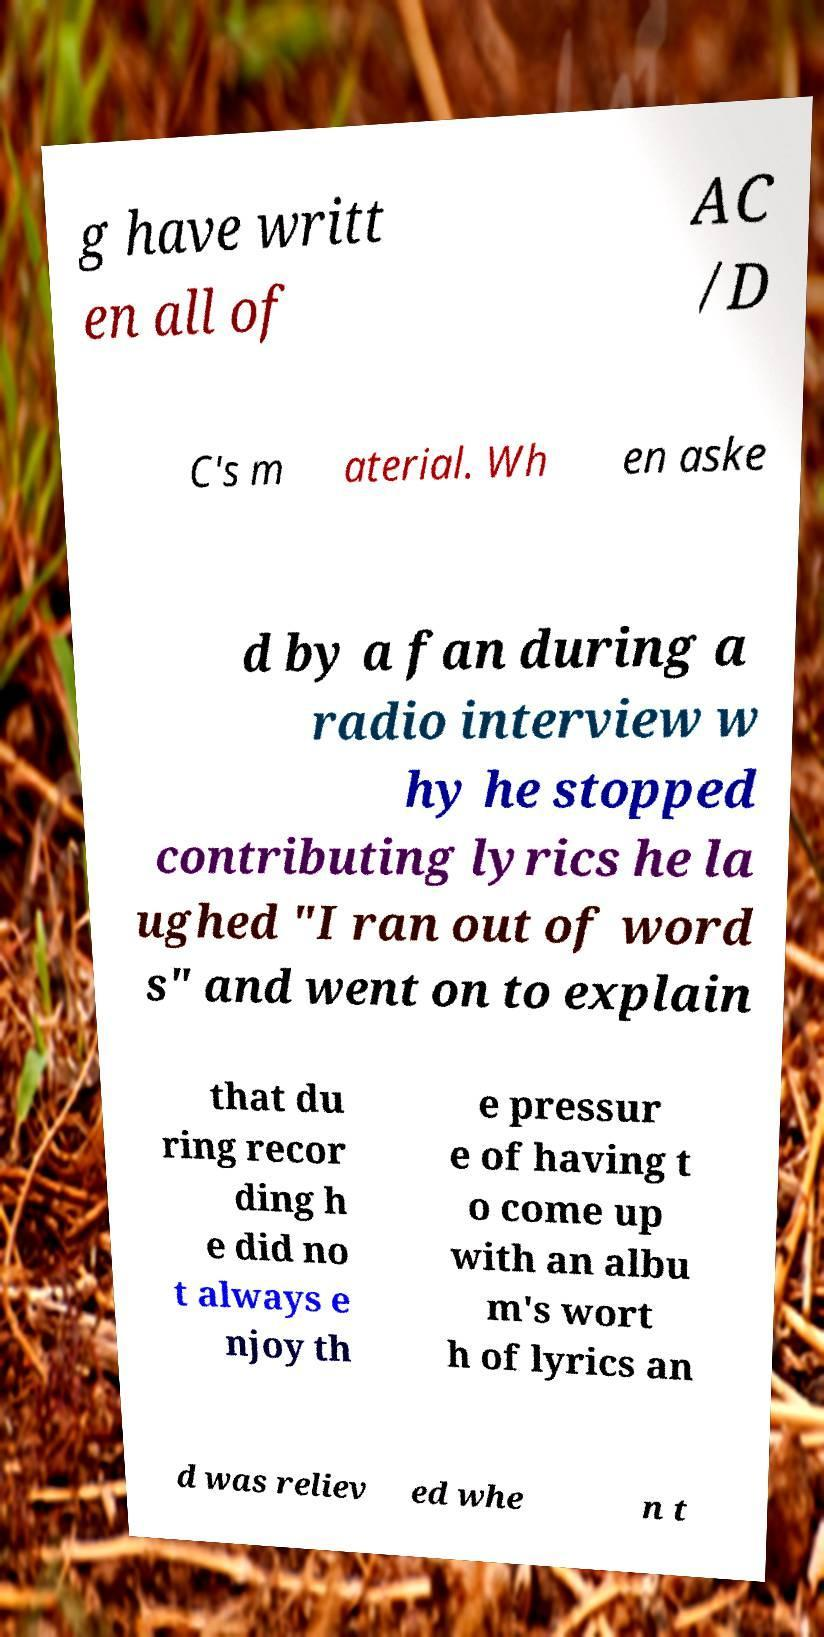Could you extract and type out the text from this image? g have writt en all of AC /D C's m aterial. Wh en aske d by a fan during a radio interview w hy he stopped contributing lyrics he la ughed "I ran out of word s" and went on to explain that du ring recor ding h e did no t always e njoy th e pressur e of having t o come up with an albu m's wort h of lyrics an d was reliev ed whe n t 